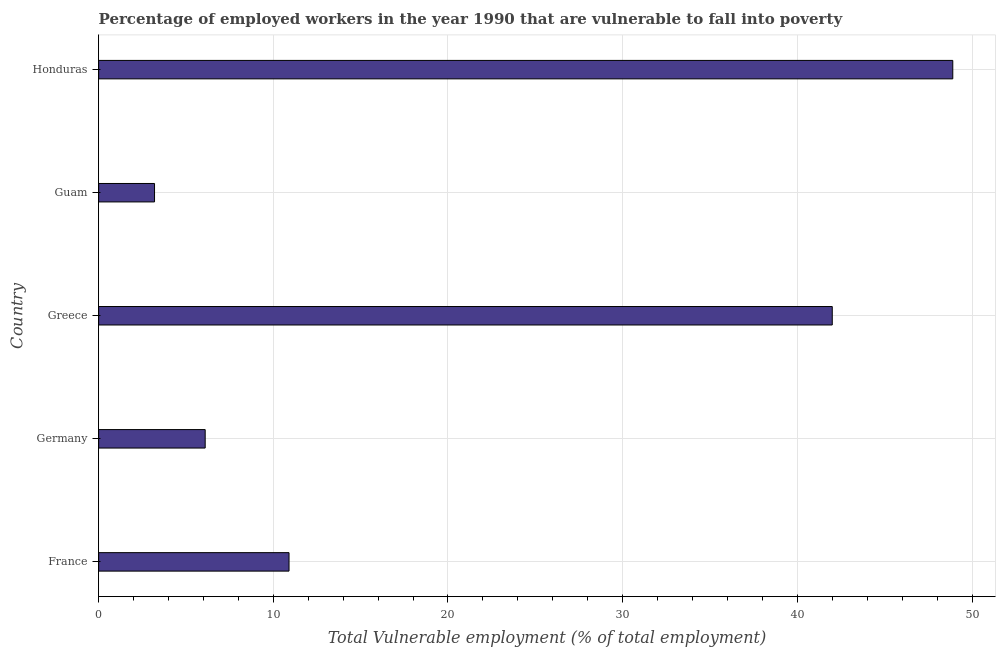Does the graph contain any zero values?
Make the answer very short. No. Does the graph contain grids?
Your answer should be compact. Yes. What is the title of the graph?
Offer a terse response. Percentage of employed workers in the year 1990 that are vulnerable to fall into poverty. What is the label or title of the X-axis?
Ensure brevity in your answer.  Total Vulnerable employment (% of total employment). What is the total vulnerable employment in Germany?
Provide a short and direct response. 6.1. Across all countries, what is the maximum total vulnerable employment?
Offer a terse response. 48.9. Across all countries, what is the minimum total vulnerable employment?
Give a very brief answer. 3.2. In which country was the total vulnerable employment maximum?
Your response must be concise. Honduras. In which country was the total vulnerable employment minimum?
Your answer should be very brief. Guam. What is the sum of the total vulnerable employment?
Your response must be concise. 111.1. What is the difference between the total vulnerable employment in France and Greece?
Offer a very short reply. -31.1. What is the average total vulnerable employment per country?
Your response must be concise. 22.22. What is the median total vulnerable employment?
Offer a terse response. 10.9. What is the ratio of the total vulnerable employment in Greece to that in Guam?
Make the answer very short. 13.12. Is the total vulnerable employment in Greece less than that in Guam?
Provide a short and direct response. No. Is the difference between the total vulnerable employment in Germany and Guam greater than the difference between any two countries?
Offer a very short reply. No. What is the difference between the highest and the second highest total vulnerable employment?
Ensure brevity in your answer.  6.9. Is the sum of the total vulnerable employment in Germany and Greece greater than the maximum total vulnerable employment across all countries?
Make the answer very short. No. What is the difference between the highest and the lowest total vulnerable employment?
Your answer should be very brief. 45.7. In how many countries, is the total vulnerable employment greater than the average total vulnerable employment taken over all countries?
Provide a short and direct response. 2. Are all the bars in the graph horizontal?
Your answer should be very brief. Yes. What is the difference between two consecutive major ticks on the X-axis?
Ensure brevity in your answer.  10. What is the Total Vulnerable employment (% of total employment) in France?
Your response must be concise. 10.9. What is the Total Vulnerable employment (% of total employment) in Germany?
Offer a very short reply. 6.1. What is the Total Vulnerable employment (% of total employment) in Guam?
Your answer should be compact. 3.2. What is the Total Vulnerable employment (% of total employment) in Honduras?
Provide a succinct answer. 48.9. What is the difference between the Total Vulnerable employment (% of total employment) in France and Germany?
Offer a terse response. 4.8. What is the difference between the Total Vulnerable employment (% of total employment) in France and Greece?
Ensure brevity in your answer.  -31.1. What is the difference between the Total Vulnerable employment (% of total employment) in France and Guam?
Ensure brevity in your answer.  7.7. What is the difference between the Total Vulnerable employment (% of total employment) in France and Honduras?
Keep it short and to the point. -38. What is the difference between the Total Vulnerable employment (% of total employment) in Germany and Greece?
Your answer should be very brief. -35.9. What is the difference between the Total Vulnerable employment (% of total employment) in Germany and Honduras?
Make the answer very short. -42.8. What is the difference between the Total Vulnerable employment (% of total employment) in Greece and Guam?
Offer a very short reply. 38.8. What is the difference between the Total Vulnerable employment (% of total employment) in Greece and Honduras?
Provide a succinct answer. -6.9. What is the difference between the Total Vulnerable employment (% of total employment) in Guam and Honduras?
Offer a terse response. -45.7. What is the ratio of the Total Vulnerable employment (% of total employment) in France to that in Germany?
Your response must be concise. 1.79. What is the ratio of the Total Vulnerable employment (% of total employment) in France to that in Greece?
Offer a very short reply. 0.26. What is the ratio of the Total Vulnerable employment (% of total employment) in France to that in Guam?
Ensure brevity in your answer.  3.41. What is the ratio of the Total Vulnerable employment (% of total employment) in France to that in Honduras?
Provide a short and direct response. 0.22. What is the ratio of the Total Vulnerable employment (% of total employment) in Germany to that in Greece?
Provide a short and direct response. 0.14. What is the ratio of the Total Vulnerable employment (% of total employment) in Germany to that in Guam?
Provide a short and direct response. 1.91. What is the ratio of the Total Vulnerable employment (% of total employment) in Germany to that in Honduras?
Give a very brief answer. 0.12. What is the ratio of the Total Vulnerable employment (% of total employment) in Greece to that in Guam?
Offer a terse response. 13.12. What is the ratio of the Total Vulnerable employment (% of total employment) in Greece to that in Honduras?
Give a very brief answer. 0.86. What is the ratio of the Total Vulnerable employment (% of total employment) in Guam to that in Honduras?
Your answer should be compact. 0.07. 